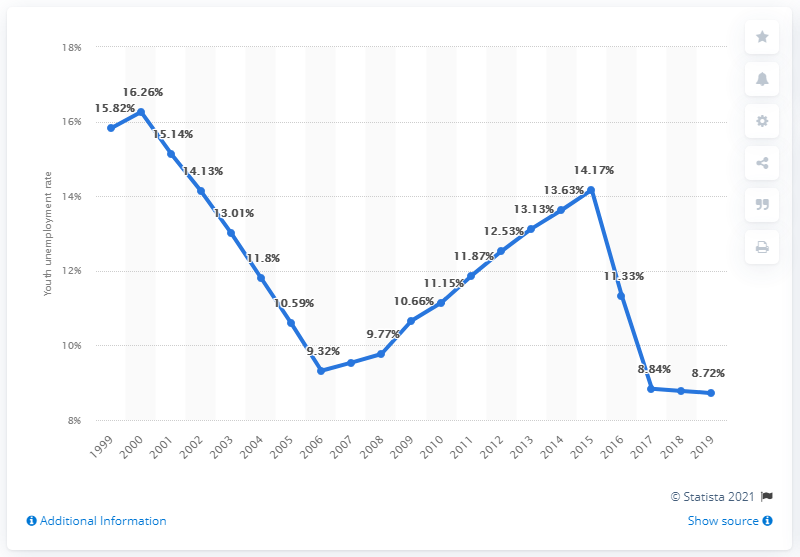Mention a couple of crucial points in this snapshot. In 2019, the youth unemployment rate in Ghana was 8.72%. 